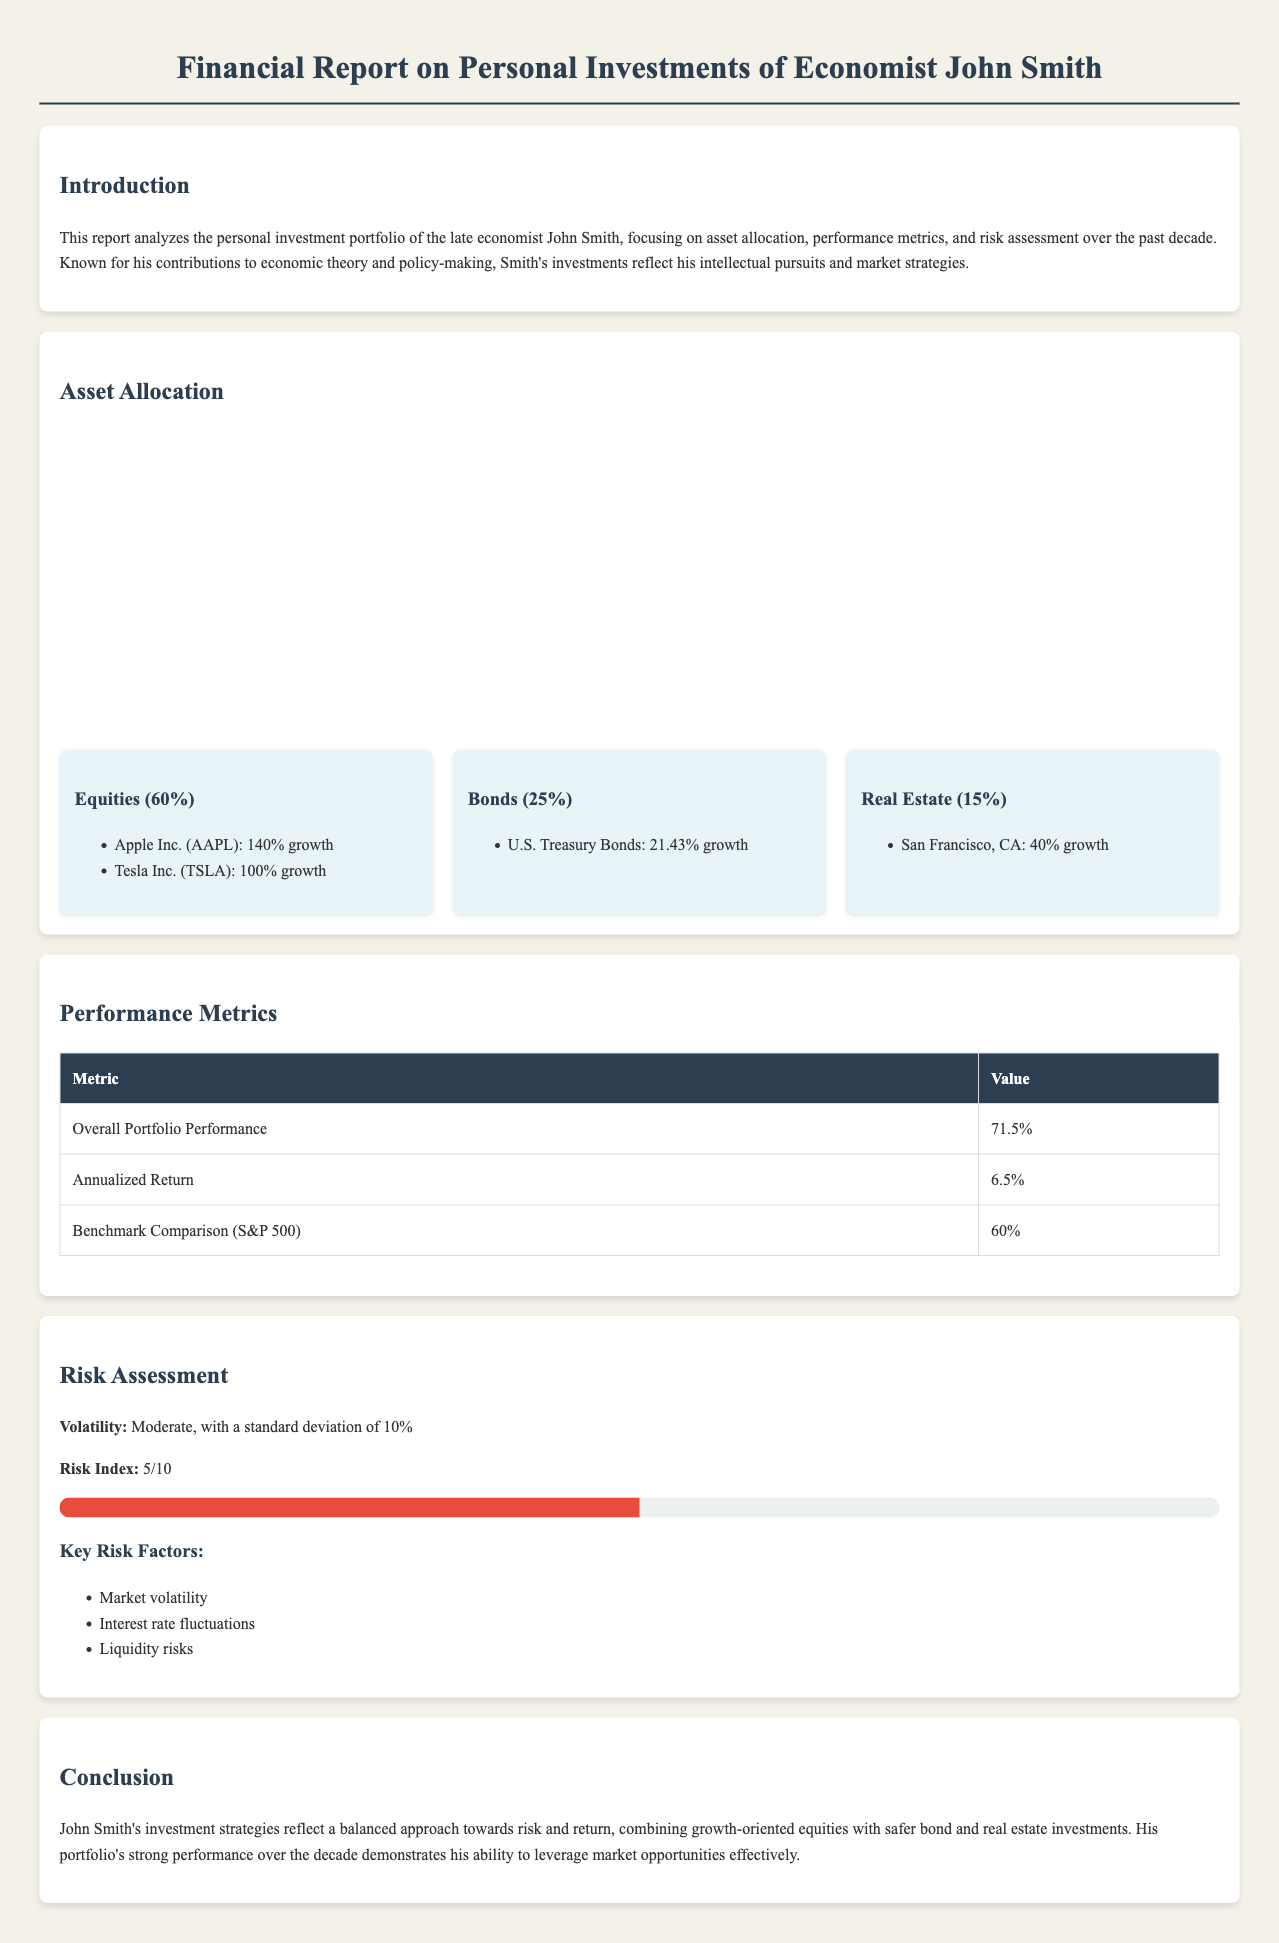What is the overall portfolio performance? The overall portfolio performance is stated in the performance metrics section of the document.
Answer: 71.5% What percentage of the portfolio is allocated to equities? The asset allocation section indicates the specific percentage allocated to each asset class.
Answer: 60% What is the annualized return of the portfolio? The annualized return can be found in the performance metrics table provided in the document.
Answer: 6.5% Which asset class had a growth of 140%? The asset allocation details the growth percentages for specific investments within each asset class.
Answer: Apple Inc. (AAPL) What is the risk index score of the portfolio? The risk assessment section provides a specific detail about the risk index score.
Answer: 5/10 What is the growth percentage of U.S. Treasury Bonds? The asset allocation card for bonds lists the growth percentage for this particular investment.
Answer: 21.43% How many key risk factors are mentioned in the report? The risk assessment section lists specific factors that contribute to the risk.
Answer: 3 What is the background color of the asset allocation chart? The document describes the visual elements and layout, including the chart's colors.
Answer: #3498db, #2ecc71, #e74c3c What is the major risk factor associated with the investments? The risk assessment section highlights key risk factors in investing.
Answer: Market volatility 